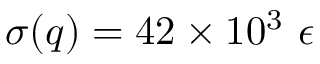<formula> <loc_0><loc_0><loc_500><loc_500>\sigma ( q ) = 4 2 \times 1 0 ^ { 3 } \ \epsilon</formula> 